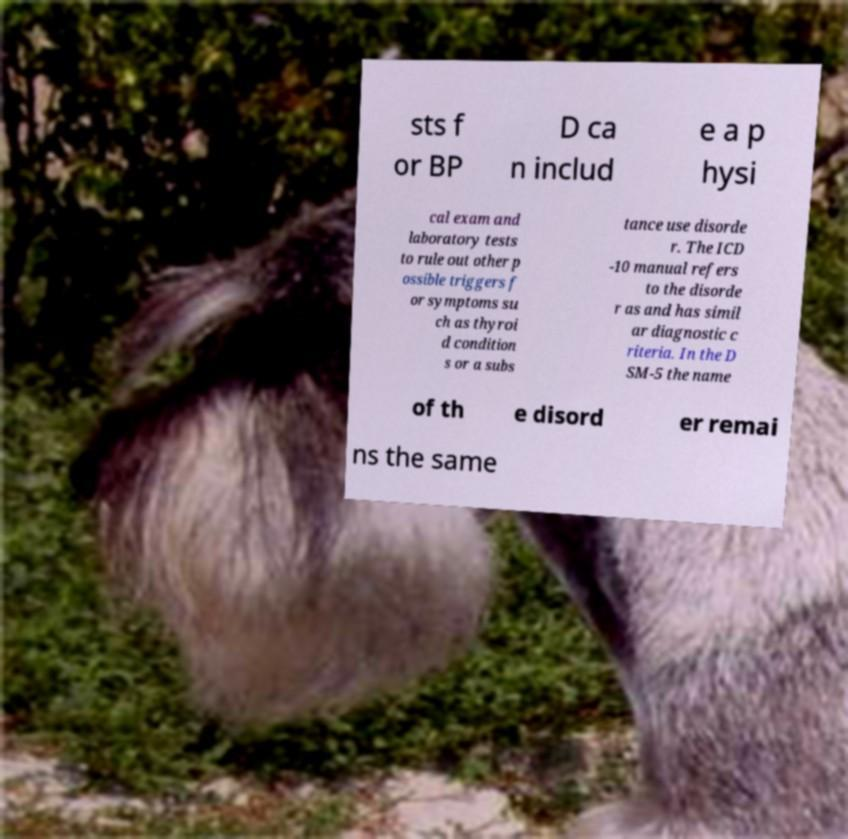What messages or text are displayed in this image? I need them in a readable, typed format. sts f or BP D ca n includ e a p hysi cal exam and laboratory tests to rule out other p ossible triggers f or symptoms su ch as thyroi d condition s or a subs tance use disorde r. The ICD -10 manual refers to the disorde r as and has simil ar diagnostic c riteria. In the D SM-5 the name of th e disord er remai ns the same 